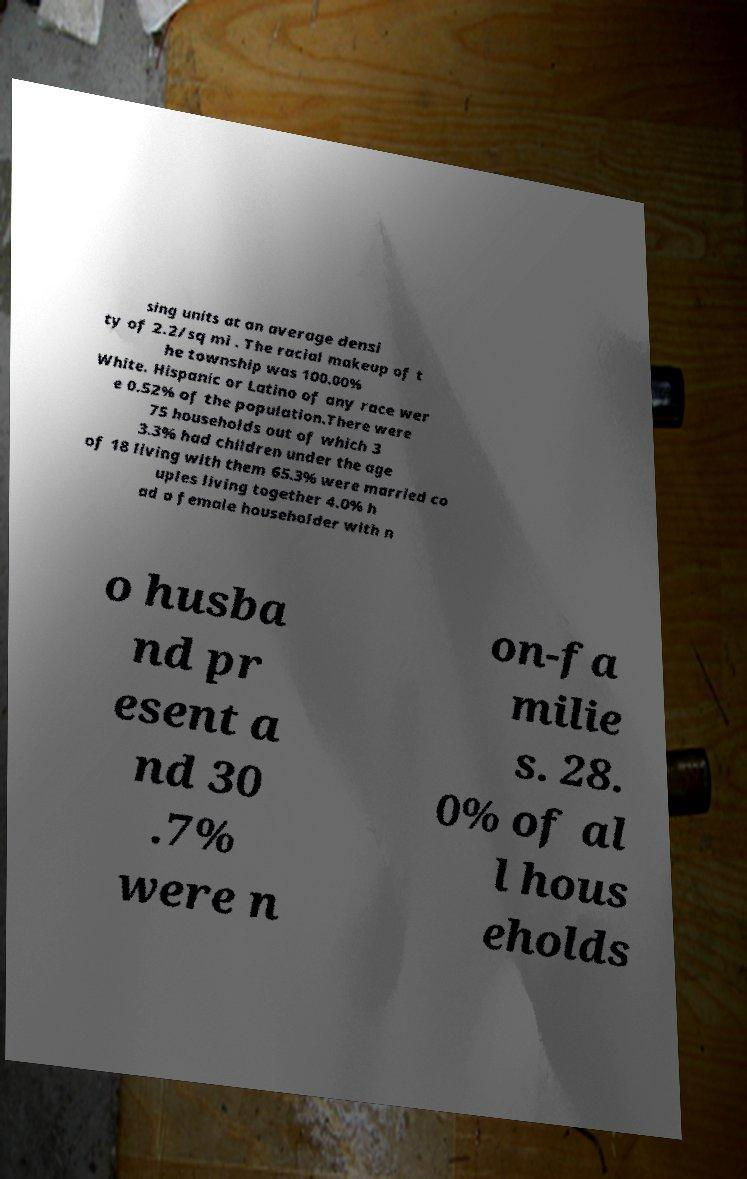Can you accurately transcribe the text from the provided image for me? sing units at an average densi ty of 2.2/sq mi . The racial makeup of t he township was 100.00% White. Hispanic or Latino of any race wer e 0.52% of the population.There were 75 households out of which 3 3.3% had children under the age of 18 living with them 65.3% were married co uples living together 4.0% h ad a female householder with n o husba nd pr esent a nd 30 .7% were n on-fa milie s. 28. 0% of al l hous eholds 